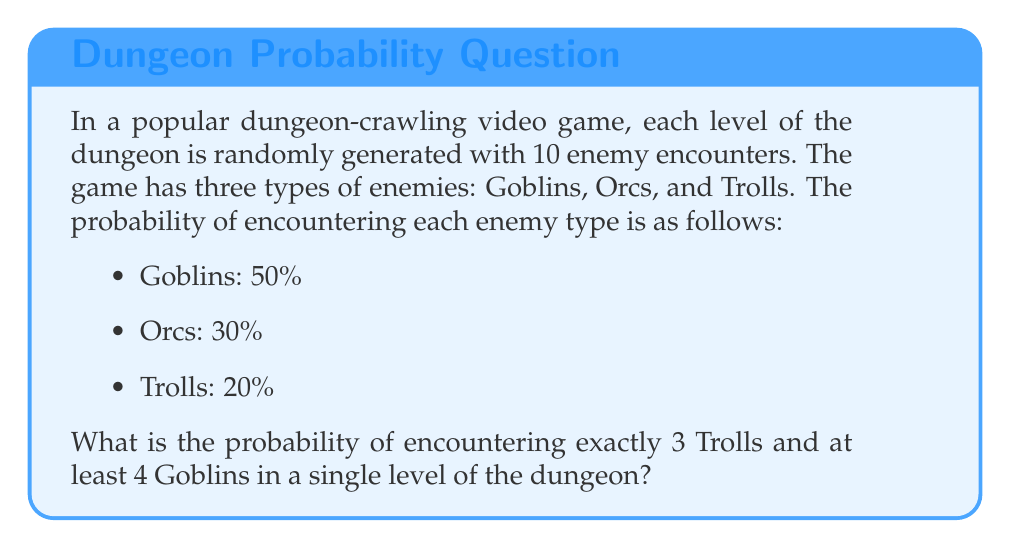Provide a solution to this math problem. Let's approach this step-by-step:

1) First, we need to use the binomial distribution to calculate the probability of encountering exactly 3 Trolls in 10 encounters.

   The probability is given by:
   $$P(\text{3 Trolls}) = \binom{10}{3} \cdot 0.2^3 \cdot 0.8^7$$

   Where $\binom{10}{3}$ is the binomial coefficient, 0.2 is the probability of encountering a Troll, and 0.8 is the probability of not encountering a Troll.

2) Next, we need to calculate the probability of encountering at least 4 Goblins in the remaining 7 encounters.

   We can use the complement of the probability of encountering 3 or fewer Goblins:
   $$P(\text{at least 4 Goblins in 7 encounters}) = 1 - P(\text{0 to 3 Goblins in 7 encounters})$$

   $$= 1 - [\binom{7}{0} \cdot 0.5^0 \cdot 0.5^7 + \binom{7}{1} \cdot 0.5^1 \cdot 0.5^6 + \binom{7}{2} \cdot 0.5^2 \cdot 0.5^5 + \binom{7}{3} \cdot 0.5^3 \cdot 0.5^4]$$

3) The probability of both events occurring is the product of their individual probabilities:

   $$P(\text{3 Trolls AND at least 4 Goblins}) = P(\text{3 Trolls}) \cdot P(\text{at least 4 Goblins in 7 encounters})$$

4) Calculating these probabilities:
   
   $P(\text{3 Trolls}) = \binom{10}{3} \cdot 0.2^3 \cdot 0.8^7 \approx 0.1206$

   $P(\text{at least 4 Goblins in 7 encounters}) \approx 0.5$

5) Therefore, the final probability is:

   $$0.1206 \cdot 0.5 \approx 0.0603$$
Answer: The probability of encountering exactly 3 Trolls and at least 4 Goblins in a single level of the dungeon is approximately 0.0603 or 6.03%. 